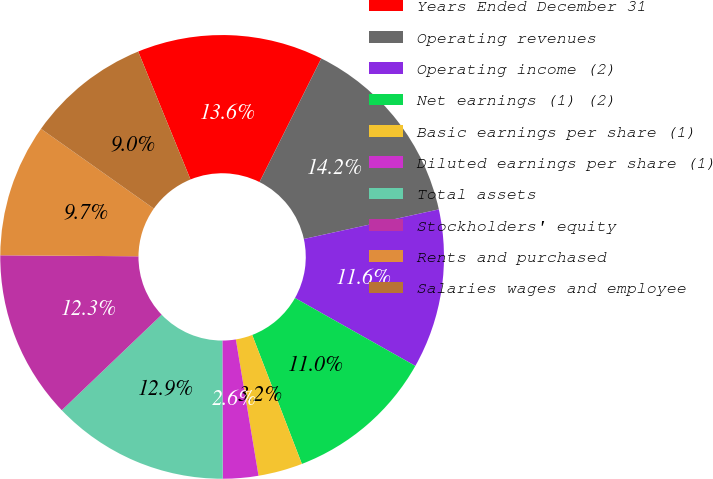Convert chart to OTSL. <chart><loc_0><loc_0><loc_500><loc_500><pie_chart><fcel>Years Ended December 31<fcel>Operating revenues<fcel>Operating income (2)<fcel>Net earnings (1) (2)<fcel>Basic earnings per share (1)<fcel>Diluted earnings per share (1)<fcel>Total assets<fcel>Stockholders' equity<fcel>Rents and purchased<fcel>Salaries wages and employee<nl><fcel>13.55%<fcel>14.19%<fcel>11.61%<fcel>10.97%<fcel>3.23%<fcel>2.58%<fcel>12.9%<fcel>12.26%<fcel>9.68%<fcel>9.03%<nl></chart> 